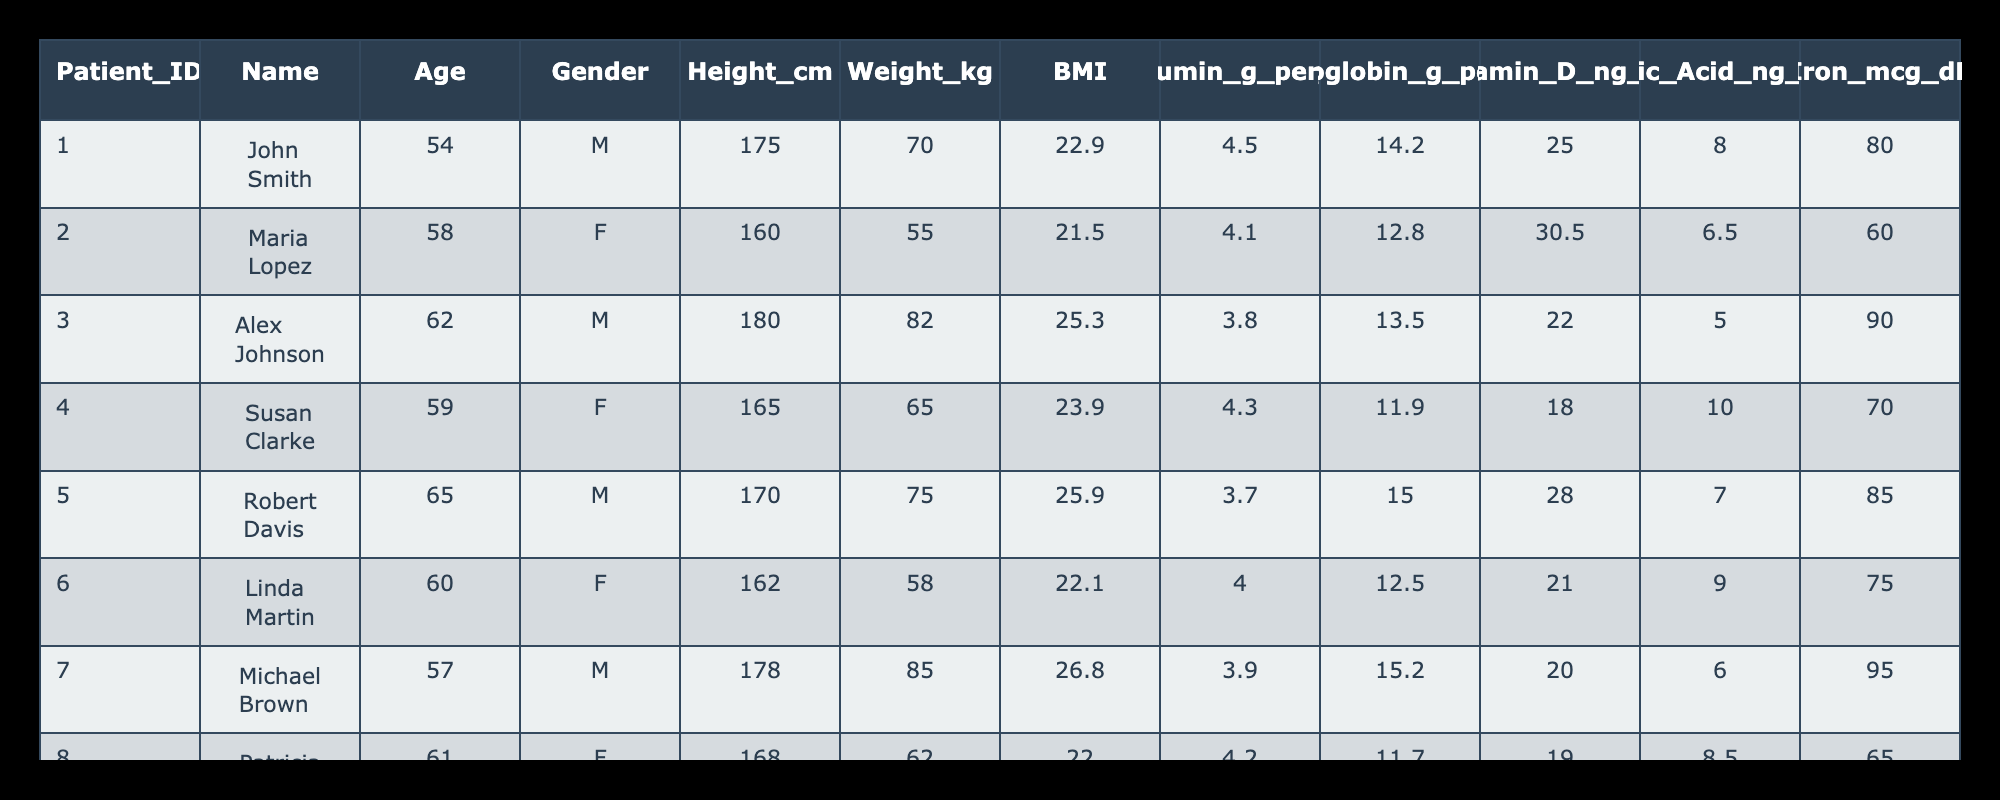What is the weight of Susan Clarke? Looking at the table, I find the row for Susan Clarke (Patient ID 004). The corresponding weight listed is 65 kg.
Answer: 65 kg What is the average age of the patients in the table? To find the average age, I calculate the sum of the ages: 54 + 58 + 62 + 59 + 65 + 60 + 57 + 61 = 436. There are 8 patients, so I divide the sum by 8: 436 / 8 = 54.5.
Answer: 54.5 Is John Smith's hemoglobin level above normal limits? Normal hemoglobin levels for adult males are around 13.5 to 17.5 g/dL. John Smith's level is 14.2 g/dL, which falls within the normal range.
Answer: Yes Which patient has the highest BMI? I will check the BMI values for each patient. The BMIs are: John Smith (22.9), Maria Lopez (21.5), Alex Johnson (25.3), Susan Clarke (23.9), Robert Davis (25.9), Linda Martin (22.1), Michael Brown (26.8), and Patricia White (22.0). Michael Brown has the highest BMI at 26.8.
Answer: Michael Brown What is the difference in Vitamin D levels between the youngest and oldest patients? The youngest patient is John Smith at age 54 with a Vitamin D level of 25.0 ng/mL, and the oldest patient is Robert Davis at age 65 with a Vitamin D level of 28.0 ng/mL. The difference is 28.0 - 25.0 = 3.0 ng/mL.
Answer: 3.0 ng/mL Are there any patients with an albumin level below 4.0 g/dL? Checking the albumin levels, I see that only Robert Davis (3.7 g/dL), Alex Johnson (3.8 g/dL), and Michael Brown (3.9 g/dL) have albumin levels below 4.0 g/dL.
Answer: Yes What is the sum of Iron levels for all female patients? The female patients and their Iron levels are Maria Lopez (60 mcg/dL), Susan Clarke (70 mcg/dL), Linda Martin (75 mcg/dL), and Patricia White (65 mcg/dL). Adding these: 60 + 70 + 75 + 65 = 270 mcg/dL.
Answer: 270 mcg/dL Which patient has the lowest Folic Acid level? Reviewing the Folic Acid levels, I find: John Smith (8.0 ng/mL), Maria Lopez (6.5 ng/mL), Alex Johnson (5.0 ng/mL), Susan Clarke (10.0 ng/mL), Robert Davis (7.0 ng/mL), Linda Martin (9.0 ng/mL), Michael Brown (6.0 ng/mL), and Patricia White (8.5 ng/mL). Alex Johnson has the lowest at 5.0 ng/mL.
Answer: Alex Johnson 